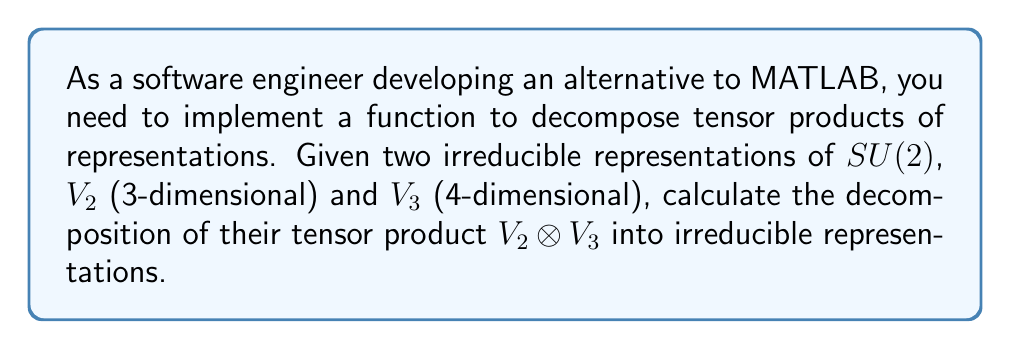Solve this math problem. To decompose the tensor product of two irreducible representations of $SU(2)$, we can use the Clebsch-Gordan formula:

$$V_j \otimes V_k \cong \bigoplus_{i=|j-k|}^{j+k} V_i$$

Where $V_j$ and $V_k$ are irreducible representations of $SU(2)$ with dimensions $2j+1$ and $2k+1$ respectively.

In this case:
1. $V_2$ has dimension 3, so $j = 1$ (since $2j+1 = 3$)
2. $V_3$ has dimension 4, so $k = \frac{3}{2}$ (since $2k+1 = 4$)

Applying the formula:

$$V_2 \otimes V_3 \cong \bigoplus_{i=|1-\frac{3}{2}|}^{1+\frac{3}{2}} V_i$$

$$\cong \bigoplus_{i=\frac{1}{2}}^{\frac{5}{2}} V_i$$

This means we sum over $i = \frac{1}{2}, \frac{3}{2}, \frac{5}{2}$

Therefore, the decomposition is:

$$V_2 \otimes V_3 \cong V_{\frac{1}{2}} \oplus V_{\frac{3}{2}} \oplus V_{\frac{5}{2}}$$

To verify dimensions:
- $V_{\frac{1}{2}}$ has dimension 2
- $V_{\frac{3}{2}}$ has dimension 4
- $V_{\frac{5}{2}}$ has dimension 6

And indeed: $2 + 4 + 6 = 12 = 3 \times 4$ (dimension of $V_2 \otimes V_3$)
Answer: $V_2 \otimes V_3 \cong V_{\frac{1}{2}} \oplus V_{\frac{3}{2}} \oplus V_{\frac{5}{2}}$ 